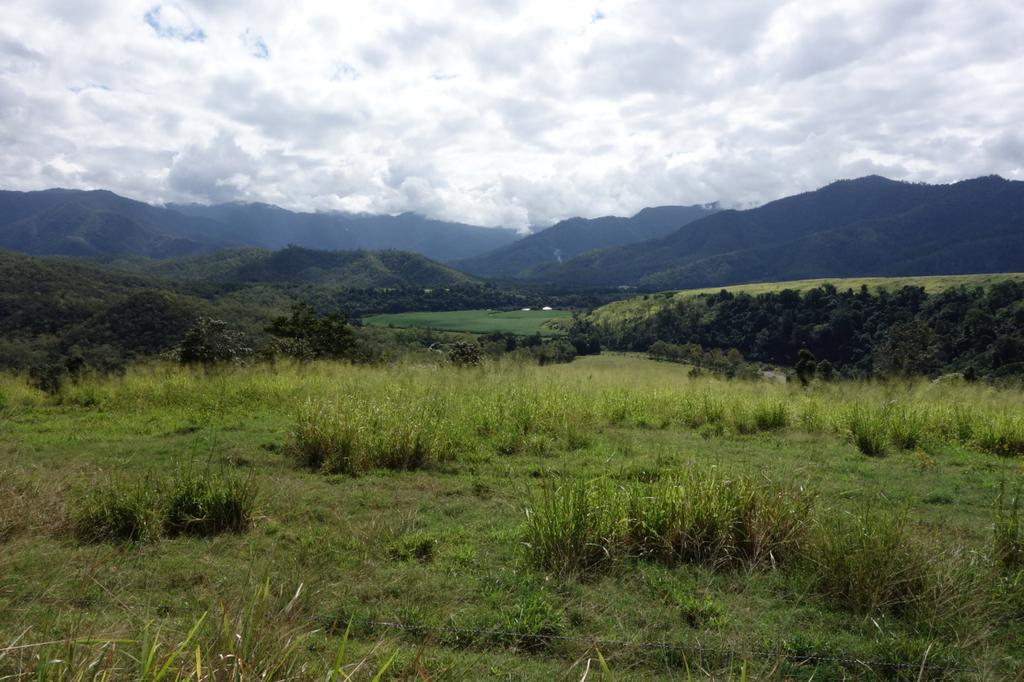What type of terrain is visible at the bottom of the image? There is grass at the bottom of the image. What type of natural formation can be seen in the background of the image? There are mountains in the background of the image. What is visible in the sky at the top of the image? There are clouds at the top of the image. What type of vegetation is present in the image? There are trees in the image. What decision was made by the game in the image? There is no game present in the image, so no decision can be attributed to it. 